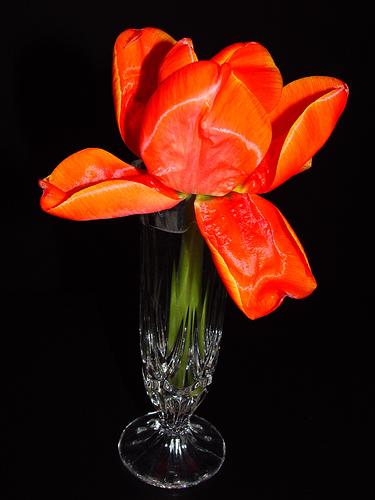Is this a crystal vase?
Give a very brief answer. Yes. What kind of flower is this?
Be succinct. Tulip. Are you able to see anything in the background in this photo?
Quick response, please. No. 